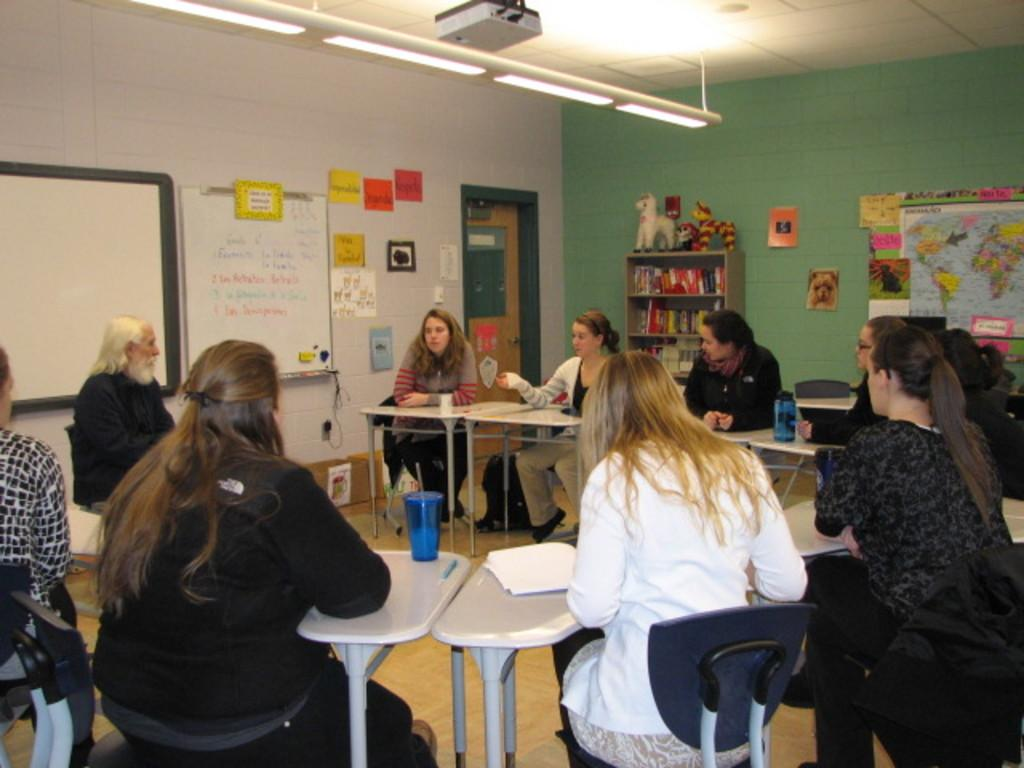How many people are in the image? There is a group of people in the image. What are the people doing in the image? The people are sitting on chairs. What is on the table in the image? There is a glass and a paper on the table. What can be seen in the background of the image? The background of the image includes a blackboard, lights, and a projector. What language is being spoken by the people in the image? There is no information about the language being spoken in the image. How many oranges are on the table in the image? There are no oranges present in the image. 